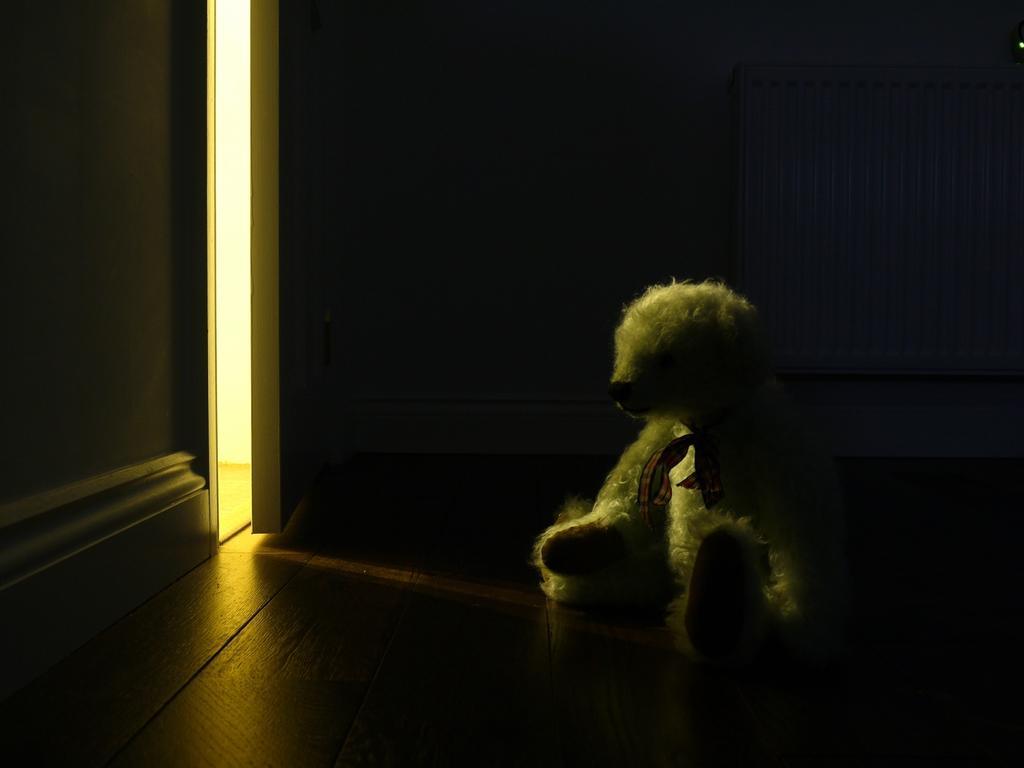Could you give a brief overview of what you see in this image? In this image I can see a white color doll on the brown color floor. In front I can see a wall and door. 